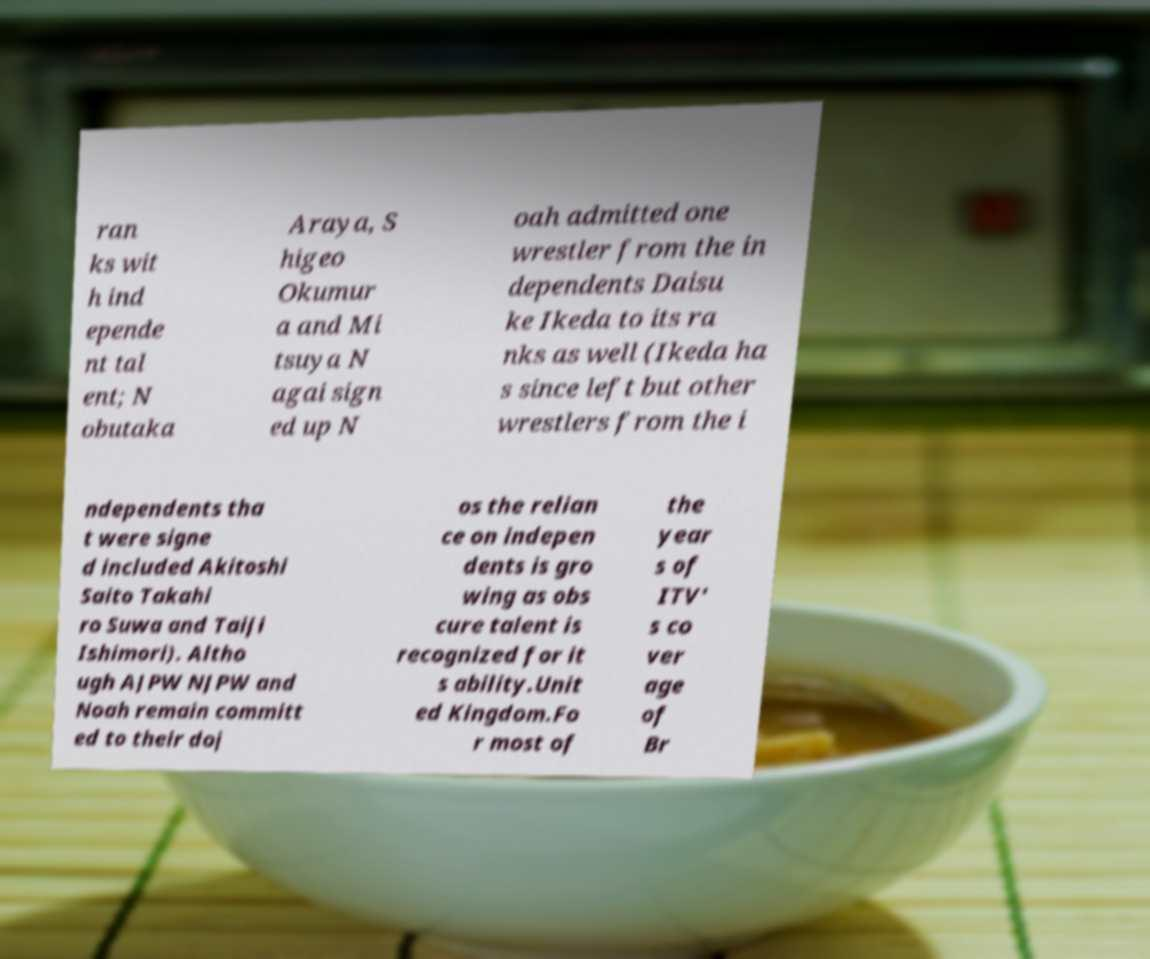For documentation purposes, I need the text within this image transcribed. Could you provide that? ran ks wit h ind epende nt tal ent; N obutaka Araya, S higeo Okumur a and Mi tsuya N agai sign ed up N oah admitted one wrestler from the in dependents Daisu ke Ikeda to its ra nks as well (Ikeda ha s since left but other wrestlers from the i ndependents tha t were signe d included Akitoshi Saito Takahi ro Suwa and Taiji Ishimori). Altho ugh AJPW NJPW and Noah remain committ ed to their doj os the relian ce on indepen dents is gro wing as obs cure talent is recognized for it s ability.Unit ed Kingdom.Fo r most of the year s of ITV' s co ver age of Br 